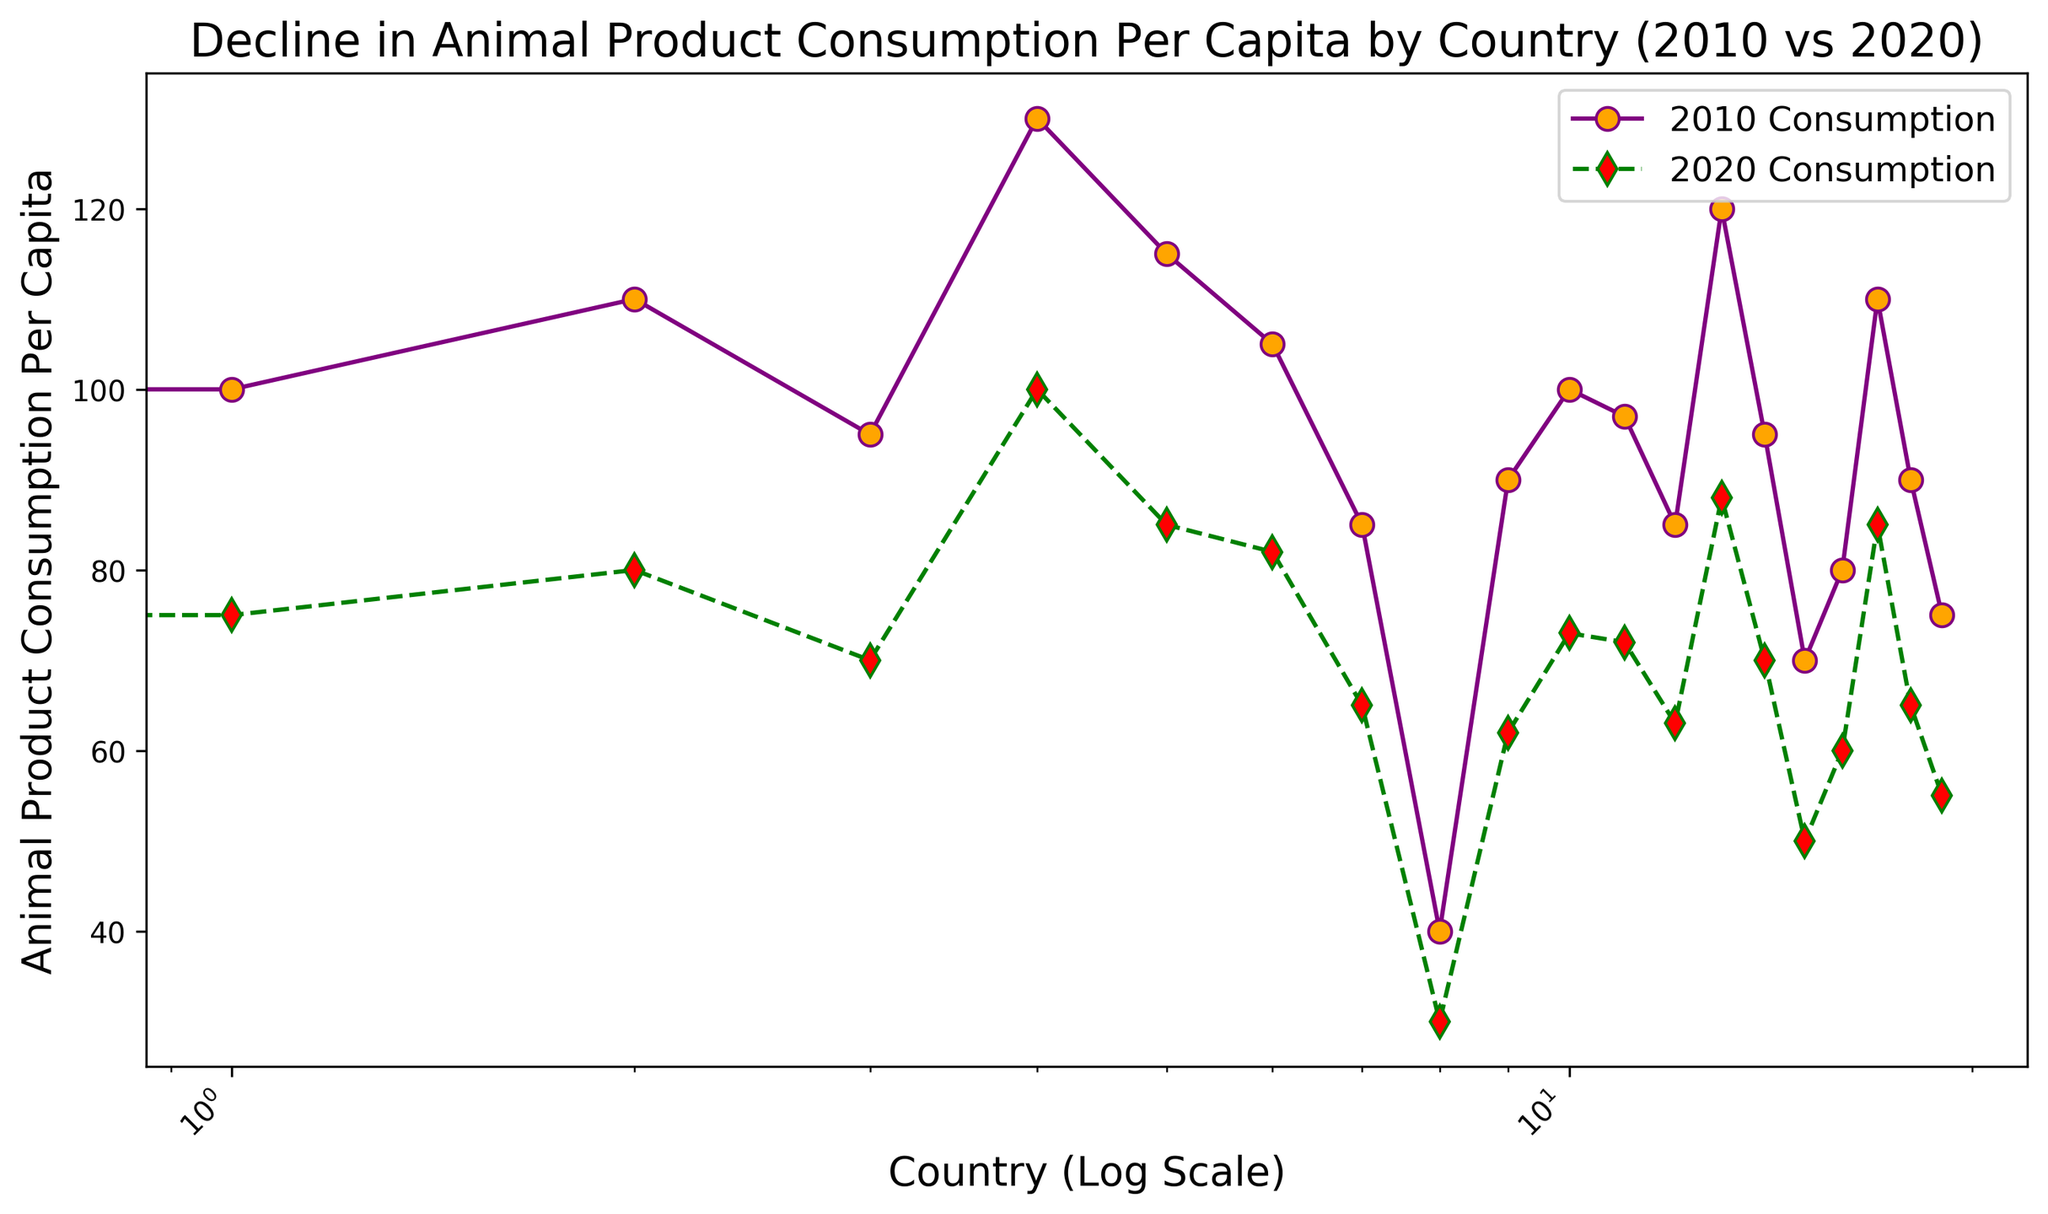Which country saw the largest absolute decline in animal product consumption between 2010 and 2020? To find the country with the largest absolute decline, calculate the difference between 2010 and 2020 consumption for each country. The country with the largest difference is the answer. For example, USA: 120-90 = 30, Germany: 100-75 = 25, etc. The country with the largest difference is the USA.
Answer: USA Which country had the smallest change in consumption from 2010 to 2020? To determine the smallest change, calculate the difference between 2010 and 2020 consumption for each country. The smallest difference is for a calculated consumption change of 10 for India.
Answer: India Is the decrease in animal product consumption larger in Japan or South Korea? Calculate the difference for each country: Japan (85-65 = 20) and South Korea (70-50 = 20). Since both have the same difference, the decrease is equal.
Answer: Equal How many countries had a 2020 consumption less than 70? From the figure, count the countries with 2020 consumption values below 70: India, Japan, China, UK, Mexico, South Korea, Turkey, and Saudi Arabia. There are 8 countries.
Answer: 8 Did any country show a decrease larger than 40 units? Check the difference for all countries. The highest difference is for the USA (120-90 = 30), which is less than 40. No country has a decrease larger than 40 units.
Answer: No Which country had a higher consumption in 2020, Canada or Germany? Compare the 2020 consumption values: Canada (85) and Germany (75). Canada has a higher consumption in 2020.
Answer: Canada What was the average consumption in 2020 for all countries listed? Add up all 2020 consumption values and divide by the number of countries: (90+75+80+70+100+85+82+65+30+62+73+72+63+88+70+50+60+85+65+55)/20. The average is approximately 72.65.
Answer: 72.65 Which country had the same relative decrease percentage between 2010 and 2020? To find relative decreases, calculate the percentage decrease for each country. For example, Germany: (100-75)/100 * 100 = 25%, and Canada: (115-85)/115 * 100 ≈ 26.09%. Multiple calculations show that no two countries have the exact same percentage decrease.
Answer: None 